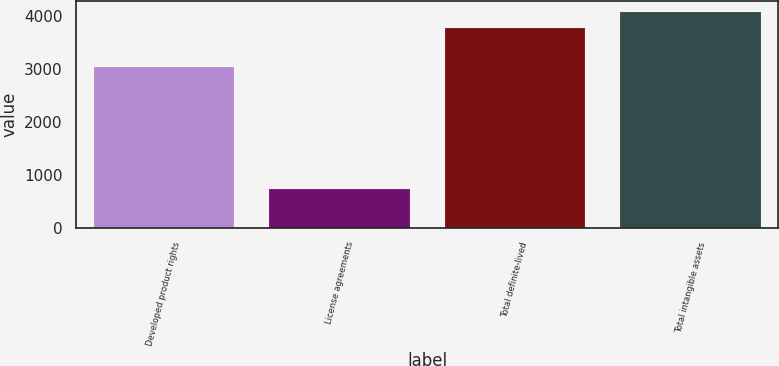<chart> <loc_0><loc_0><loc_500><loc_500><bar_chart><fcel>Developed product rights<fcel>License agreements<fcel>Total definite-lived<fcel>Total intangible assets<nl><fcel>3031<fcel>734<fcel>3765<fcel>4068.1<nl></chart> 